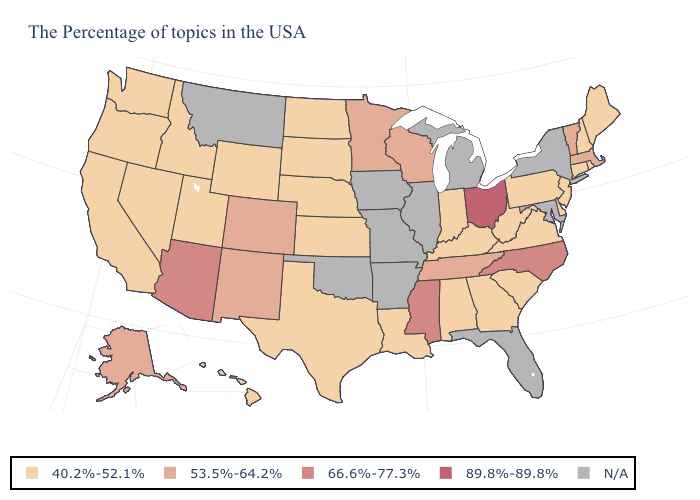How many symbols are there in the legend?
Answer briefly. 5. What is the value of Nevada?
Give a very brief answer. 40.2%-52.1%. What is the value of Arizona?
Quick response, please. 66.6%-77.3%. Which states hav the highest value in the MidWest?
Quick response, please. Ohio. What is the value of Delaware?
Write a very short answer. 40.2%-52.1%. What is the value of Maine?
Quick response, please. 40.2%-52.1%. What is the value of New Mexico?
Answer briefly. 53.5%-64.2%. What is the highest value in the USA?
Write a very short answer. 89.8%-89.8%. Name the states that have a value in the range 89.8%-89.8%?
Concise answer only. Ohio. Name the states that have a value in the range 53.5%-64.2%?
Be succinct. Massachusetts, Vermont, Tennessee, Wisconsin, Minnesota, Colorado, New Mexico, Alaska. What is the value of California?
Answer briefly. 40.2%-52.1%. Does Vermont have the highest value in the Northeast?
Write a very short answer. Yes. Does the first symbol in the legend represent the smallest category?
Concise answer only. Yes. Among the states that border New York , does Pennsylvania have the lowest value?
Write a very short answer. Yes. What is the value of Nevada?
Give a very brief answer. 40.2%-52.1%. 